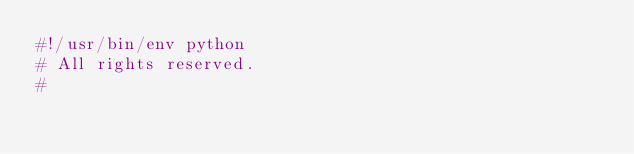Convert code to text. <code><loc_0><loc_0><loc_500><loc_500><_Python_>#!/usr/bin/env python
# All rights reserved.
#</code> 